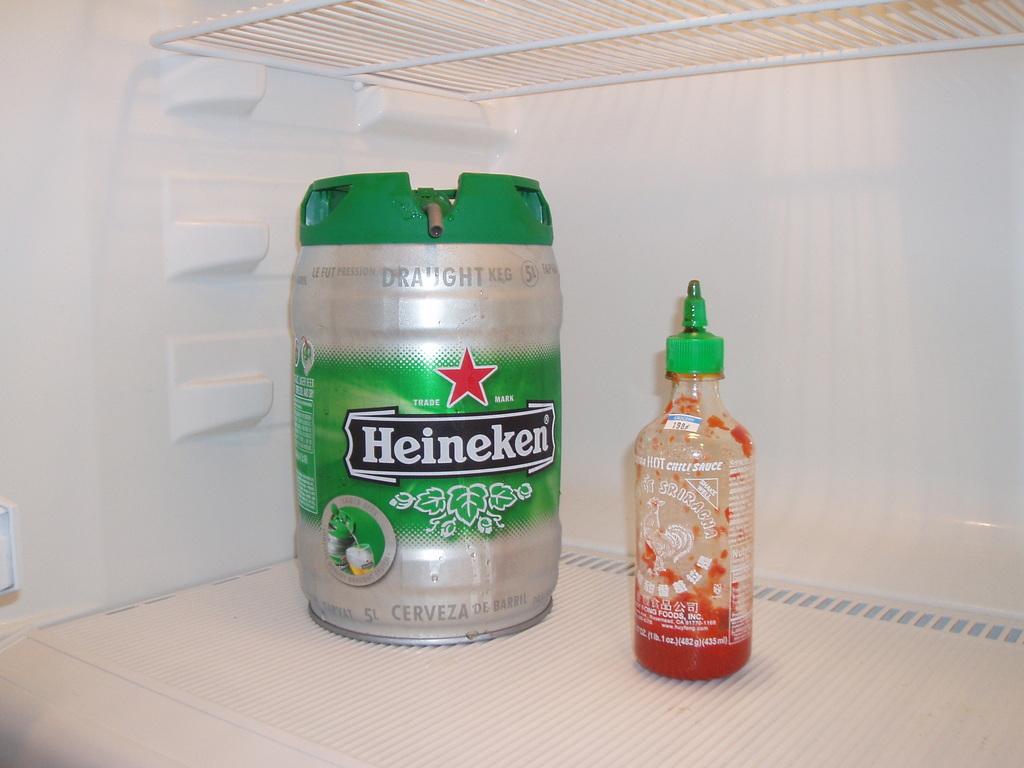What brand name is on the hot chili sauce bottle?
Give a very brief answer. Sriracha. What brand of beer is on the container on the left?
Offer a very short reply. Heineken. 